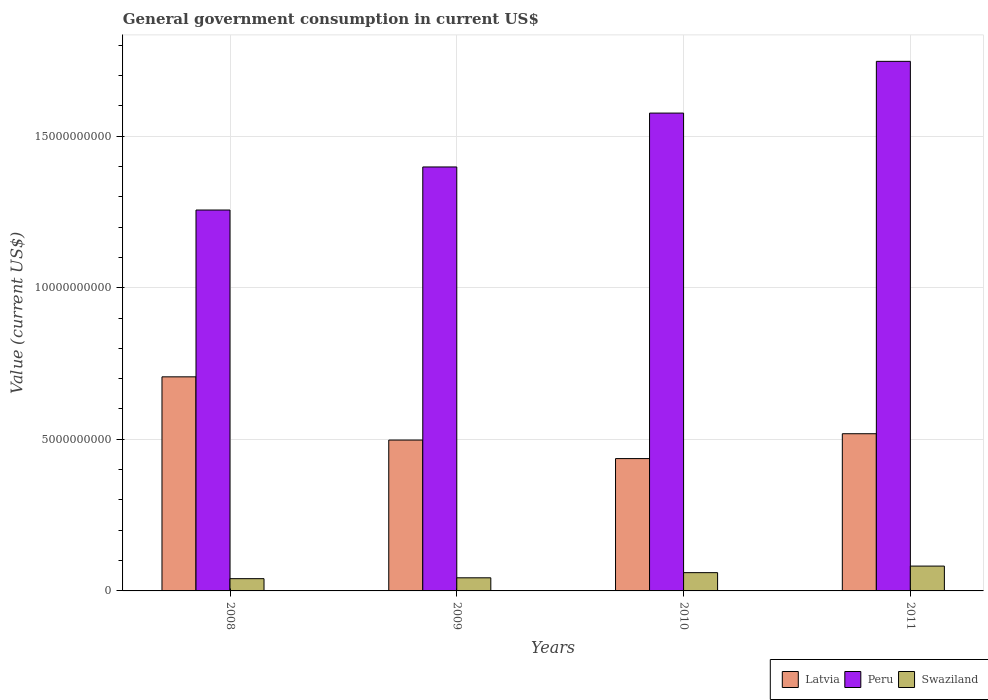Are the number of bars per tick equal to the number of legend labels?
Your response must be concise. Yes. In how many cases, is the number of bars for a given year not equal to the number of legend labels?
Provide a short and direct response. 0. What is the government conusmption in Swaziland in 2010?
Ensure brevity in your answer.  6.03e+08. Across all years, what is the maximum government conusmption in Latvia?
Offer a terse response. 7.06e+09. Across all years, what is the minimum government conusmption in Swaziland?
Offer a terse response. 4.04e+08. What is the total government conusmption in Latvia in the graph?
Offer a terse response. 2.16e+1. What is the difference between the government conusmption in Latvia in 2010 and that in 2011?
Provide a succinct answer. -8.20e+08. What is the difference between the government conusmption in Swaziland in 2011 and the government conusmption in Latvia in 2009?
Your answer should be compact. -4.16e+09. What is the average government conusmption in Peru per year?
Ensure brevity in your answer.  1.49e+1. In the year 2010, what is the difference between the government conusmption in Swaziland and government conusmption in Latvia?
Keep it short and to the point. -3.76e+09. In how many years, is the government conusmption in Latvia greater than 1000000000 US$?
Make the answer very short. 4. What is the ratio of the government conusmption in Latvia in 2009 to that in 2011?
Ensure brevity in your answer.  0.96. What is the difference between the highest and the second highest government conusmption in Peru?
Provide a succinct answer. 1.71e+09. What is the difference between the highest and the lowest government conusmption in Peru?
Provide a short and direct response. 4.90e+09. Is the sum of the government conusmption in Swaziland in 2010 and 2011 greater than the maximum government conusmption in Latvia across all years?
Keep it short and to the point. No. What does the 1st bar from the right in 2011 represents?
Give a very brief answer. Swaziland. How many years are there in the graph?
Ensure brevity in your answer.  4. Are the values on the major ticks of Y-axis written in scientific E-notation?
Provide a succinct answer. No. Where does the legend appear in the graph?
Keep it short and to the point. Bottom right. How are the legend labels stacked?
Ensure brevity in your answer.  Horizontal. What is the title of the graph?
Offer a very short reply. General government consumption in current US$. Does "Ukraine" appear as one of the legend labels in the graph?
Offer a terse response. No. What is the label or title of the Y-axis?
Your response must be concise. Value (current US$). What is the Value (current US$) of Latvia in 2008?
Give a very brief answer. 7.06e+09. What is the Value (current US$) in Peru in 2008?
Give a very brief answer. 1.26e+1. What is the Value (current US$) of Swaziland in 2008?
Keep it short and to the point. 4.04e+08. What is the Value (current US$) of Latvia in 2009?
Offer a very short reply. 4.98e+09. What is the Value (current US$) of Peru in 2009?
Make the answer very short. 1.40e+1. What is the Value (current US$) in Swaziland in 2009?
Make the answer very short. 4.32e+08. What is the Value (current US$) of Latvia in 2010?
Make the answer very short. 4.36e+09. What is the Value (current US$) in Peru in 2010?
Give a very brief answer. 1.58e+1. What is the Value (current US$) in Swaziland in 2010?
Your answer should be compact. 6.03e+08. What is the Value (current US$) in Latvia in 2011?
Your answer should be very brief. 5.18e+09. What is the Value (current US$) of Peru in 2011?
Provide a succinct answer. 1.75e+1. What is the Value (current US$) of Swaziland in 2011?
Provide a short and direct response. 8.19e+08. Across all years, what is the maximum Value (current US$) in Latvia?
Offer a very short reply. 7.06e+09. Across all years, what is the maximum Value (current US$) of Peru?
Ensure brevity in your answer.  1.75e+1. Across all years, what is the maximum Value (current US$) in Swaziland?
Make the answer very short. 8.19e+08. Across all years, what is the minimum Value (current US$) in Latvia?
Offer a terse response. 4.36e+09. Across all years, what is the minimum Value (current US$) in Peru?
Ensure brevity in your answer.  1.26e+1. Across all years, what is the minimum Value (current US$) of Swaziland?
Offer a terse response. 4.04e+08. What is the total Value (current US$) of Latvia in the graph?
Offer a very short reply. 2.16e+1. What is the total Value (current US$) of Peru in the graph?
Give a very brief answer. 5.98e+1. What is the total Value (current US$) in Swaziland in the graph?
Give a very brief answer. 2.26e+09. What is the difference between the Value (current US$) in Latvia in 2008 and that in 2009?
Give a very brief answer. 2.09e+09. What is the difference between the Value (current US$) of Peru in 2008 and that in 2009?
Ensure brevity in your answer.  -1.42e+09. What is the difference between the Value (current US$) of Swaziland in 2008 and that in 2009?
Provide a succinct answer. -2.83e+07. What is the difference between the Value (current US$) of Latvia in 2008 and that in 2010?
Your answer should be very brief. 2.70e+09. What is the difference between the Value (current US$) in Peru in 2008 and that in 2010?
Give a very brief answer. -3.20e+09. What is the difference between the Value (current US$) of Swaziland in 2008 and that in 2010?
Provide a short and direct response. -1.99e+08. What is the difference between the Value (current US$) of Latvia in 2008 and that in 2011?
Offer a terse response. 1.88e+09. What is the difference between the Value (current US$) of Peru in 2008 and that in 2011?
Provide a succinct answer. -4.90e+09. What is the difference between the Value (current US$) in Swaziland in 2008 and that in 2011?
Offer a terse response. -4.15e+08. What is the difference between the Value (current US$) in Latvia in 2009 and that in 2010?
Your answer should be very brief. 6.11e+08. What is the difference between the Value (current US$) of Peru in 2009 and that in 2010?
Ensure brevity in your answer.  -1.78e+09. What is the difference between the Value (current US$) in Swaziland in 2009 and that in 2010?
Offer a terse response. -1.70e+08. What is the difference between the Value (current US$) in Latvia in 2009 and that in 2011?
Offer a very short reply. -2.09e+08. What is the difference between the Value (current US$) in Peru in 2009 and that in 2011?
Your answer should be compact. -3.48e+09. What is the difference between the Value (current US$) of Swaziland in 2009 and that in 2011?
Your answer should be very brief. -3.87e+08. What is the difference between the Value (current US$) in Latvia in 2010 and that in 2011?
Make the answer very short. -8.20e+08. What is the difference between the Value (current US$) of Peru in 2010 and that in 2011?
Offer a terse response. -1.71e+09. What is the difference between the Value (current US$) in Swaziland in 2010 and that in 2011?
Your answer should be very brief. -2.16e+08. What is the difference between the Value (current US$) in Latvia in 2008 and the Value (current US$) in Peru in 2009?
Keep it short and to the point. -6.92e+09. What is the difference between the Value (current US$) in Latvia in 2008 and the Value (current US$) in Swaziland in 2009?
Offer a terse response. 6.63e+09. What is the difference between the Value (current US$) in Peru in 2008 and the Value (current US$) in Swaziland in 2009?
Give a very brief answer. 1.21e+1. What is the difference between the Value (current US$) of Latvia in 2008 and the Value (current US$) of Peru in 2010?
Offer a terse response. -8.70e+09. What is the difference between the Value (current US$) of Latvia in 2008 and the Value (current US$) of Swaziland in 2010?
Offer a terse response. 6.46e+09. What is the difference between the Value (current US$) in Peru in 2008 and the Value (current US$) in Swaziland in 2010?
Offer a very short reply. 1.20e+1. What is the difference between the Value (current US$) in Latvia in 2008 and the Value (current US$) in Peru in 2011?
Offer a terse response. -1.04e+1. What is the difference between the Value (current US$) in Latvia in 2008 and the Value (current US$) in Swaziland in 2011?
Your response must be concise. 6.24e+09. What is the difference between the Value (current US$) of Peru in 2008 and the Value (current US$) of Swaziland in 2011?
Your response must be concise. 1.17e+1. What is the difference between the Value (current US$) of Latvia in 2009 and the Value (current US$) of Peru in 2010?
Your answer should be compact. -1.08e+1. What is the difference between the Value (current US$) in Latvia in 2009 and the Value (current US$) in Swaziland in 2010?
Offer a terse response. 4.37e+09. What is the difference between the Value (current US$) of Peru in 2009 and the Value (current US$) of Swaziland in 2010?
Your answer should be compact. 1.34e+1. What is the difference between the Value (current US$) of Latvia in 2009 and the Value (current US$) of Peru in 2011?
Keep it short and to the point. -1.25e+1. What is the difference between the Value (current US$) in Latvia in 2009 and the Value (current US$) in Swaziland in 2011?
Keep it short and to the point. 4.16e+09. What is the difference between the Value (current US$) of Peru in 2009 and the Value (current US$) of Swaziland in 2011?
Provide a succinct answer. 1.32e+1. What is the difference between the Value (current US$) in Latvia in 2010 and the Value (current US$) in Peru in 2011?
Make the answer very short. -1.31e+1. What is the difference between the Value (current US$) in Latvia in 2010 and the Value (current US$) in Swaziland in 2011?
Make the answer very short. 3.55e+09. What is the difference between the Value (current US$) of Peru in 2010 and the Value (current US$) of Swaziland in 2011?
Make the answer very short. 1.49e+1. What is the average Value (current US$) in Latvia per year?
Your answer should be compact. 5.40e+09. What is the average Value (current US$) in Peru per year?
Provide a succinct answer. 1.49e+1. What is the average Value (current US$) of Swaziland per year?
Keep it short and to the point. 5.65e+08. In the year 2008, what is the difference between the Value (current US$) in Latvia and Value (current US$) in Peru?
Offer a very short reply. -5.50e+09. In the year 2008, what is the difference between the Value (current US$) of Latvia and Value (current US$) of Swaziland?
Provide a succinct answer. 6.66e+09. In the year 2008, what is the difference between the Value (current US$) in Peru and Value (current US$) in Swaziland?
Make the answer very short. 1.22e+1. In the year 2009, what is the difference between the Value (current US$) in Latvia and Value (current US$) in Peru?
Your answer should be very brief. -9.01e+09. In the year 2009, what is the difference between the Value (current US$) in Latvia and Value (current US$) in Swaziland?
Provide a succinct answer. 4.54e+09. In the year 2009, what is the difference between the Value (current US$) of Peru and Value (current US$) of Swaziland?
Keep it short and to the point. 1.35e+1. In the year 2010, what is the difference between the Value (current US$) in Latvia and Value (current US$) in Peru?
Your response must be concise. -1.14e+1. In the year 2010, what is the difference between the Value (current US$) of Latvia and Value (current US$) of Swaziland?
Keep it short and to the point. 3.76e+09. In the year 2010, what is the difference between the Value (current US$) of Peru and Value (current US$) of Swaziland?
Make the answer very short. 1.52e+1. In the year 2011, what is the difference between the Value (current US$) in Latvia and Value (current US$) in Peru?
Give a very brief answer. -1.23e+1. In the year 2011, what is the difference between the Value (current US$) of Latvia and Value (current US$) of Swaziland?
Offer a very short reply. 4.37e+09. In the year 2011, what is the difference between the Value (current US$) of Peru and Value (current US$) of Swaziland?
Provide a succinct answer. 1.66e+1. What is the ratio of the Value (current US$) in Latvia in 2008 to that in 2009?
Ensure brevity in your answer.  1.42. What is the ratio of the Value (current US$) of Peru in 2008 to that in 2009?
Your answer should be very brief. 0.9. What is the ratio of the Value (current US$) in Swaziland in 2008 to that in 2009?
Your answer should be compact. 0.93. What is the ratio of the Value (current US$) in Latvia in 2008 to that in 2010?
Offer a very short reply. 1.62. What is the ratio of the Value (current US$) in Peru in 2008 to that in 2010?
Keep it short and to the point. 0.8. What is the ratio of the Value (current US$) in Swaziland in 2008 to that in 2010?
Your response must be concise. 0.67. What is the ratio of the Value (current US$) of Latvia in 2008 to that in 2011?
Offer a terse response. 1.36. What is the ratio of the Value (current US$) in Peru in 2008 to that in 2011?
Your answer should be very brief. 0.72. What is the ratio of the Value (current US$) in Swaziland in 2008 to that in 2011?
Your answer should be compact. 0.49. What is the ratio of the Value (current US$) in Latvia in 2009 to that in 2010?
Provide a succinct answer. 1.14. What is the ratio of the Value (current US$) in Peru in 2009 to that in 2010?
Offer a very short reply. 0.89. What is the ratio of the Value (current US$) in Swaziland in 2009 to that in 2010?
Give a very brief answer. 0.72. What is the ratio of the Value (current US$) of Latvia in 2009 to that in 2011?
Offer a very short reply. 0.96. What is the ratio of the Value (current US$) of Peru in 2009 to that in 2011?
Provide a short and direct response. 0.8. What is the ratio of the Value (current US$) in Swaziland in 2009 to that in 2011?
Your answer should be compact. 0.53. What is the ratio of the Value (current US$) in Latvia in 2010 to that in 2011?
Your answer should be compact. 0.84. What is the ratio of the Value (current US$) of Peru in 2010 to that in 2011?
Make the answer very short. 0.9. What is the ratio of the Value (current US$) in Swaziland in 2010 to that in 2011?
Ensure brevity in your answer.  0.74. What is the difference between the highest and the second highest Value (current US$) in Latvia?
Ensure brevity in your answer.  1.88e+09. What is the difference between the highest and the second highest Value (current US$) of Peru?
Ensure brevity in your answer.  1.71e+09. What is the difference between the highest and the second highest Value (current US$) of Swaziland?
Your answer should be very brief. 2.16e+08. What is the difference between the highest and the lowest Value (current US$) of Latvia?
Offer a terse response. 2.70e+09. What is the difference between the highest and the lowest Value (current US$) in Peru?
Your answer should be compact. 4.90e+09. What is the difference between the highest and the lowest Value (current US$) in Swaziland?
Provide a succinct answer. 4.15e+08. 